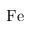<formula> <loc_0><loc_0><loc_500><loc_500>F e</formula> 